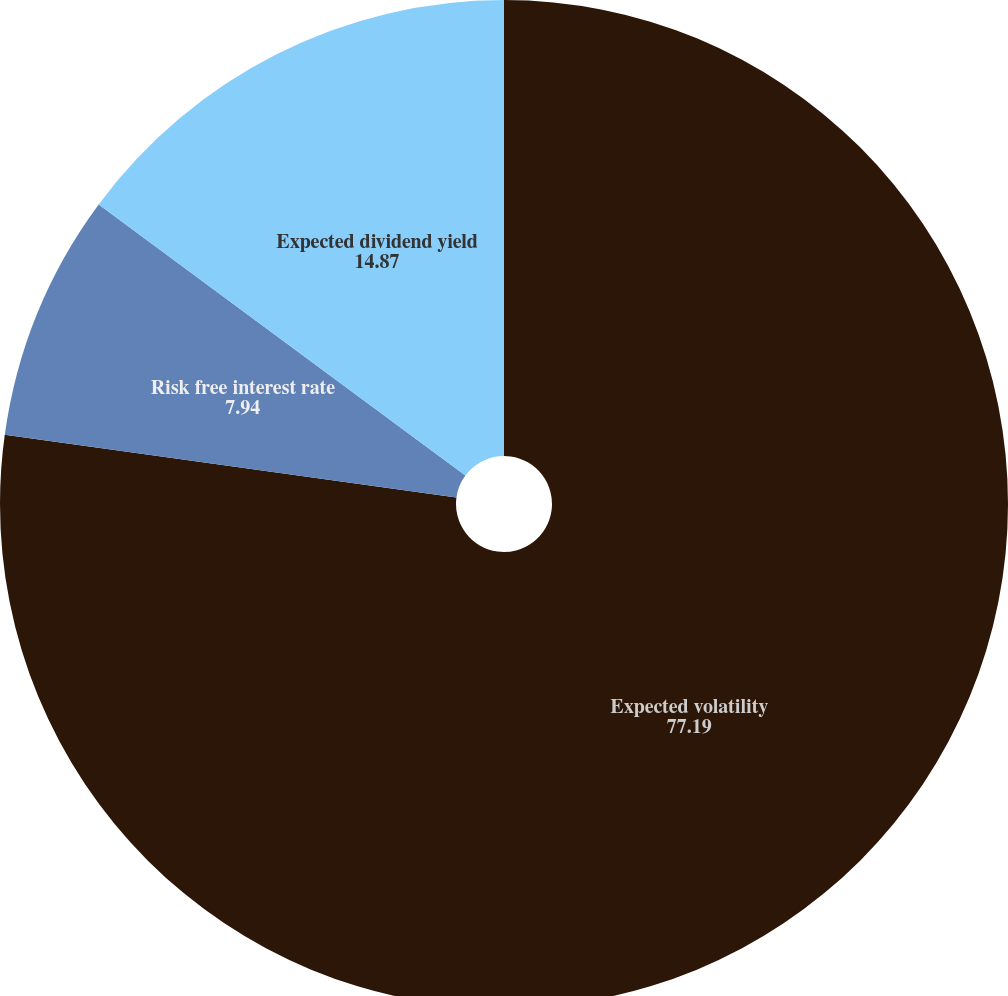Convert chart. <chart><loc_0><loc_0><loc_500><loc_500><pie_chart><fcel>Expected volatility<fcel>Risk free interest rate<fcel>Expected dividend yield<nl><fcel>77.19%<fcel>7.94%<fcel>14.87%<nl></chart> 